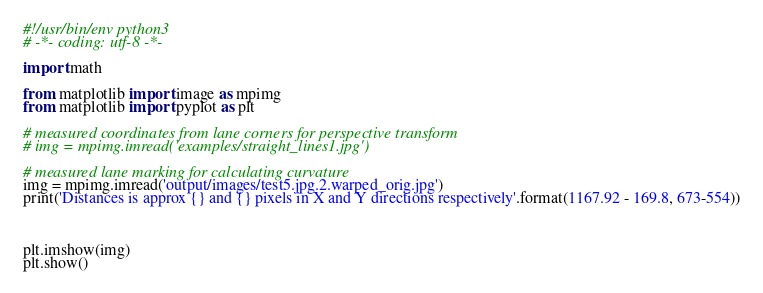<code> <loc_0><loc_0><loc_500><loc_500><_Python_>#!/usr/bin/env python3
# -*- coding: utf-8 -*-

import math

from matplotlib import image as mpimg
from matplotlib import pyplot as plt

# measured coordinates from lane corners for perspective transform
# img = mpimg.imread('examples/straight_lines1.jpg')

# measured lane marking for calculating curvature
img = mpimg.imread('output/images/test5.jpg.2.warped_orig.jpg')
print('Distances is approx {} and {} pixels in X and Y directions respectively'.format(1167.92 - 169.8, 673-554))



plt.imshow(img)
plt.show()
</code> 